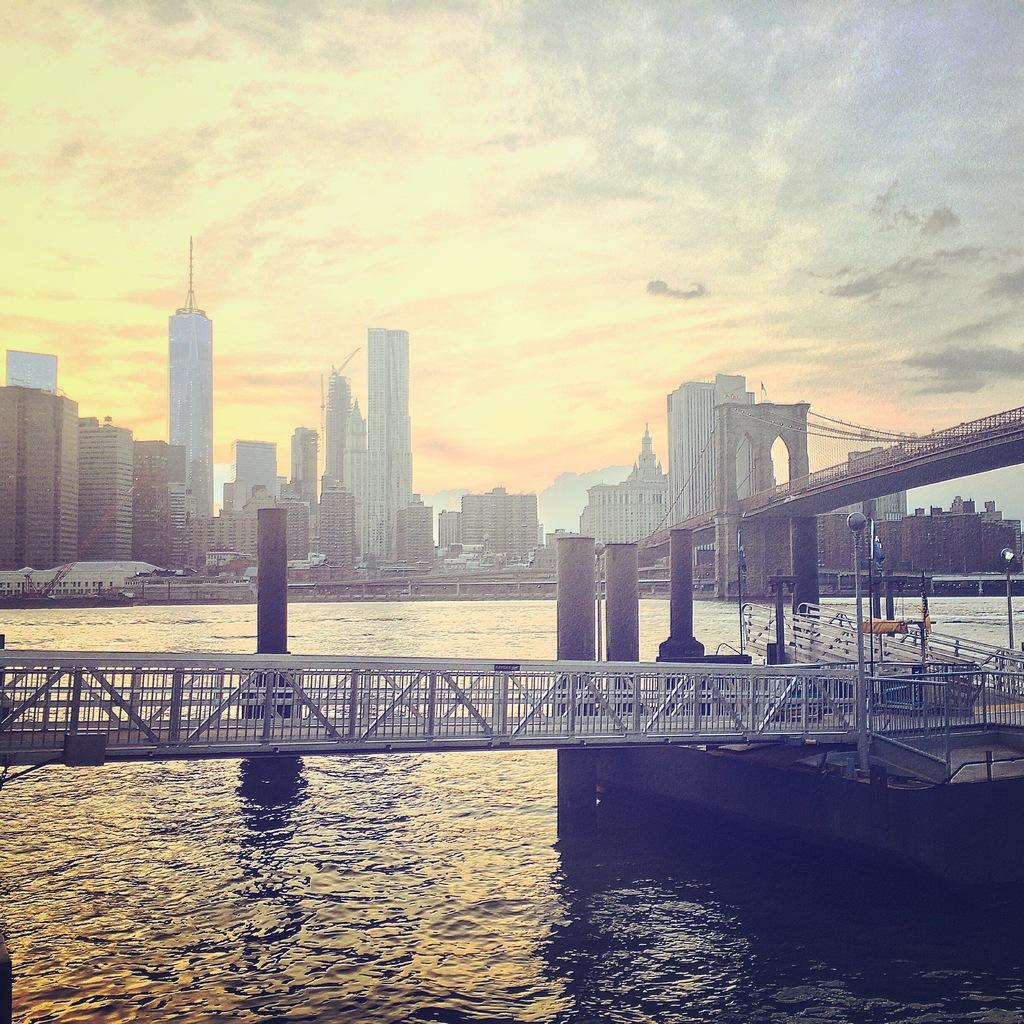What structure can be seen in the image? There is a bridge in the image. What natural element is visible in the image? There is water visible in the image. What can be seen in the distance in the image? There are buildings and the sky visible in the background of the image. What is the condition of the sky in the image? The sky is visible in the background of the image, and there are clouds present. What type of coat is the bridge wearing in the image? There is no coat present in the image, as bridges do not wear clothing. 